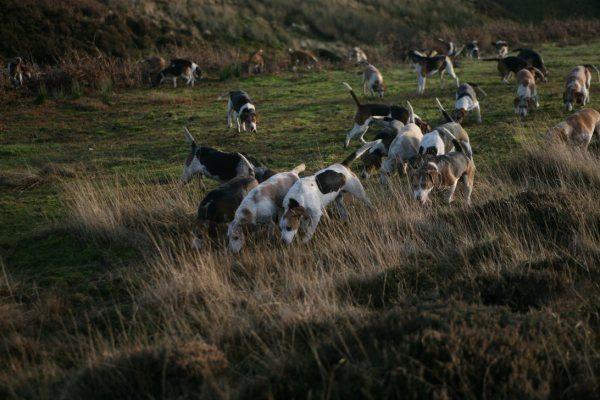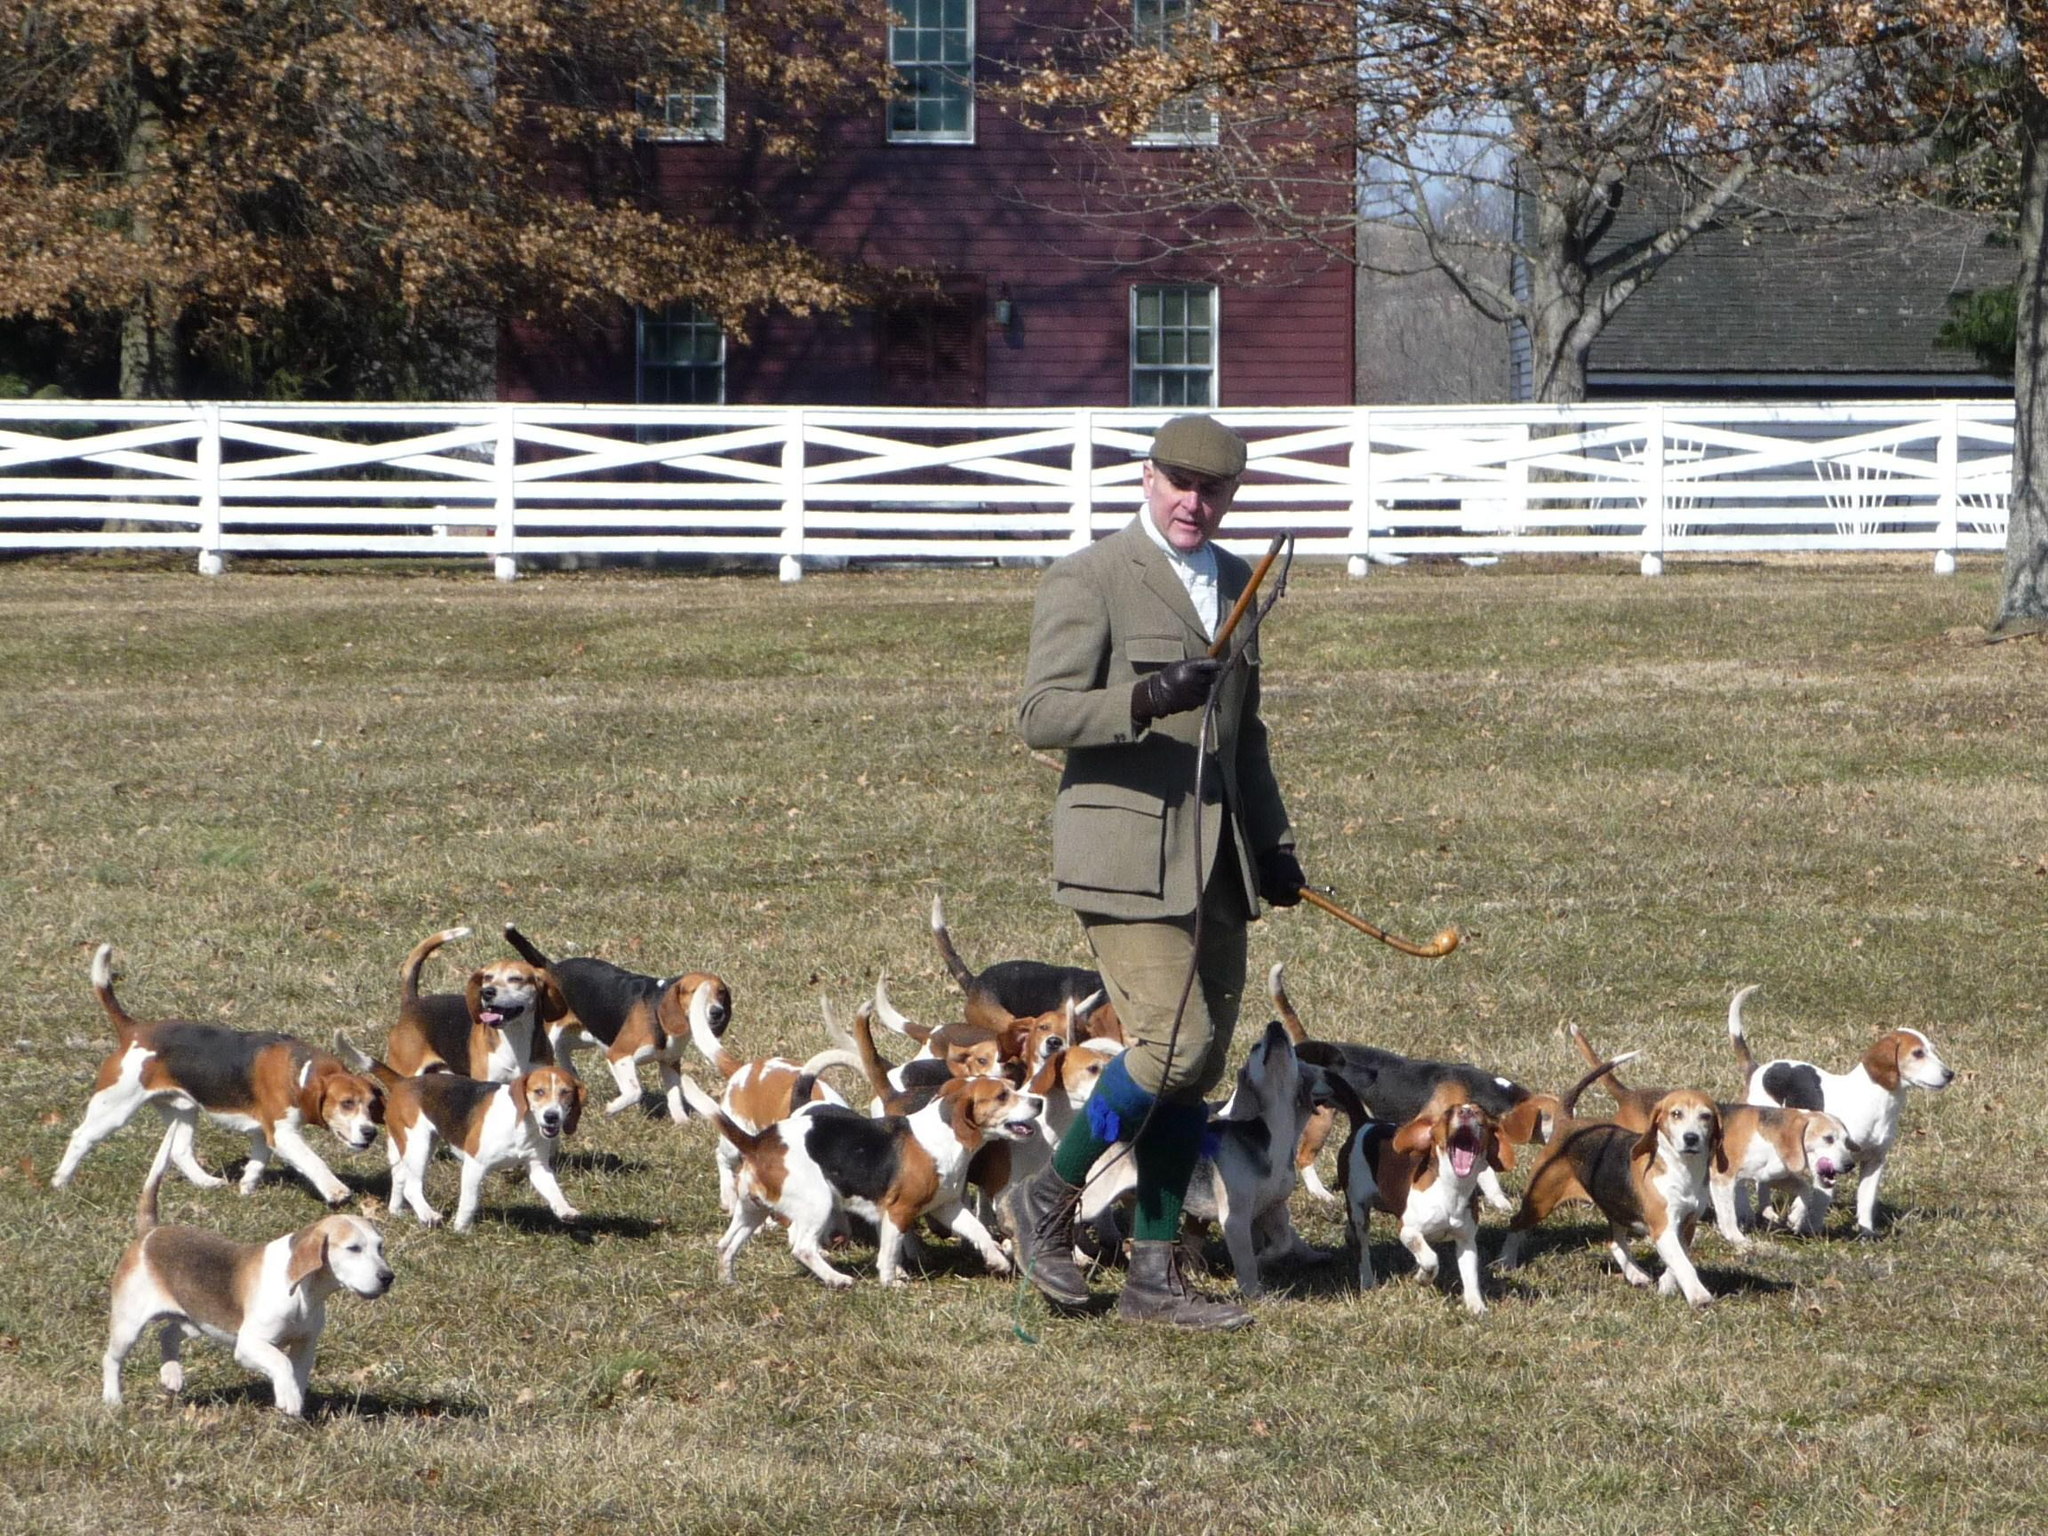The first image is the image on the left, the second image is the image on the right. Given the left and right images, does the statement "One of the images shows a single man surrounded by a group of hunting dogs." hold true? Answer yes or no. Yes. The first image is the image on the left, the second image is the image on the right. For the images displayed, is the sentence "There is no more than one human in the right image." factually correct? Answer yes or no. Yes. 